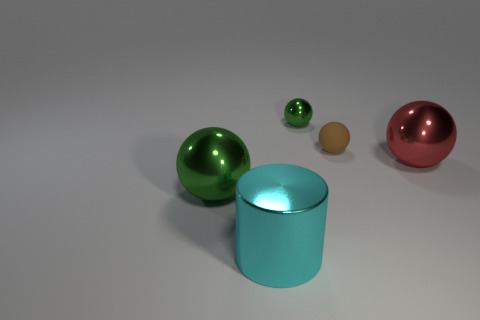Subtract all blue cylinders. How many green balls are left? 2 Subtract 1 balls. How many balls are left? 3 Subtract all tiny metal balls. How many balls are left? 3 Subtract all red balls. How many balls are left? 3 Add 1 big brown rubber things. How many objects exist? 6 Subtract all balls. How many objects are left? 1 Subtract all cyan balls. Subtract all purple cylinders. How many balls are left? 4 Add 5 small gray metallic cylinders. How many small gray metallic cylinders exist? 5 Subtract 1 red balls. How many objects are left? 4 Subtract all brown rubber blocks. Subtract all shiny balls. How many objects are left? 2 